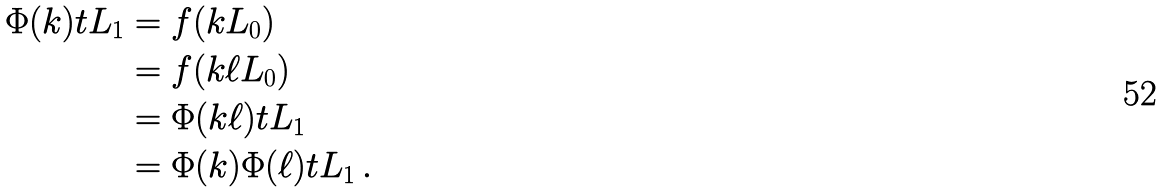<formula> <loc_0><loc_0><loc_500><loc_500>\Phi ( k ) t L _ { 1 } & = f ( k L _ { 0 } ) \\ & = f ( k \ell L _ { 0 } ) \\ & = \Phi ( k \ell ) t L _ { 1 } \\ & = \Phi ( k ) \Phi ( \ell ) t L _ { 1 } \, .</formula> 